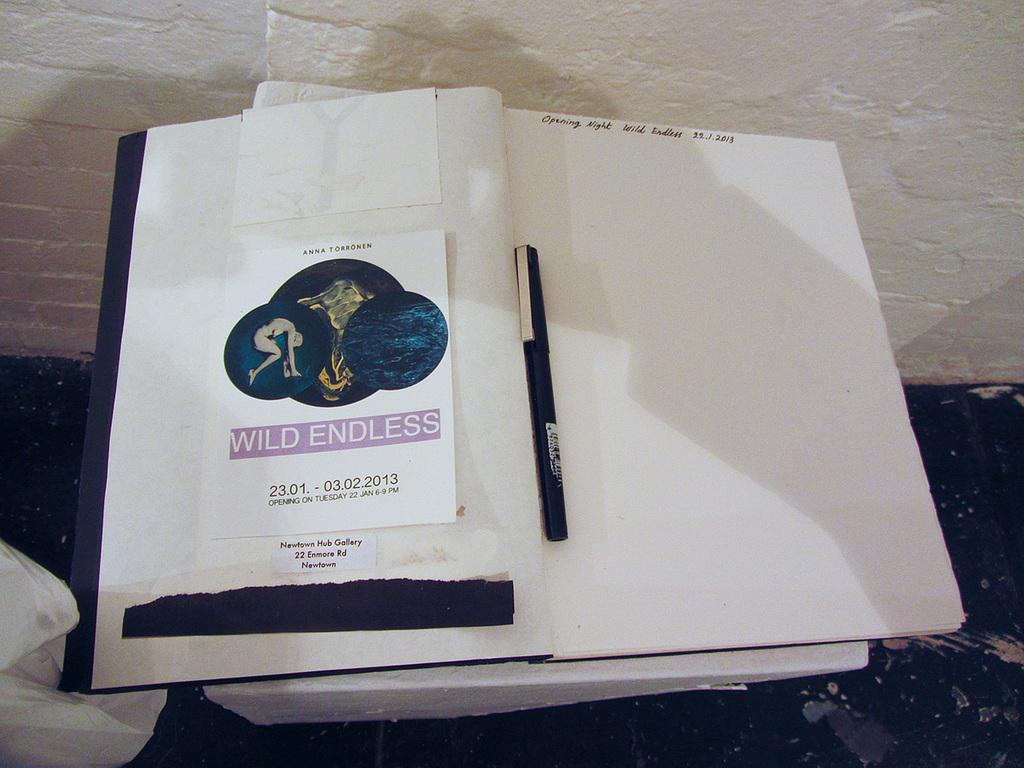What writing instrument is visible in the image? There is a pen in the image. What is the pen used for in the image? The pen is likely used for writing or drawing, as it is next to a book. What is the book used for in the image? The book is likely used for reading or studying, as it is accompanied by a pen. What can be seen in the background of the image? There is a wall and a surface in the background of the image. What other objects are present in the image? There are other objects in the image, but their specific details are not mentioned in the provided facts. How many notes are being taken by the tiger in the image? There is no tiger present in the image, and therefore no tiger can be taking notes. 